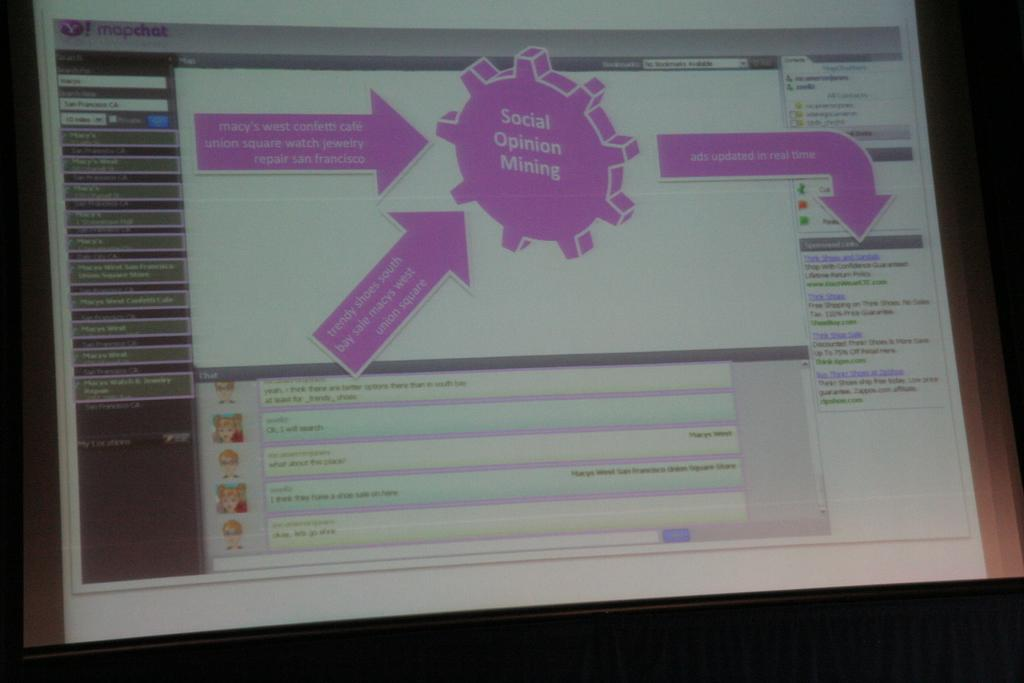<image>
Create a compact narrative representing the image presented. Social opinion mining displays on a computer screen. 